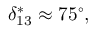<formula> <loc_0><loc_0><loc_500><loc_500>\delta _ { 1 3 } ^ { * } \approx 7 5 ^ { \circ } ,</formula> 